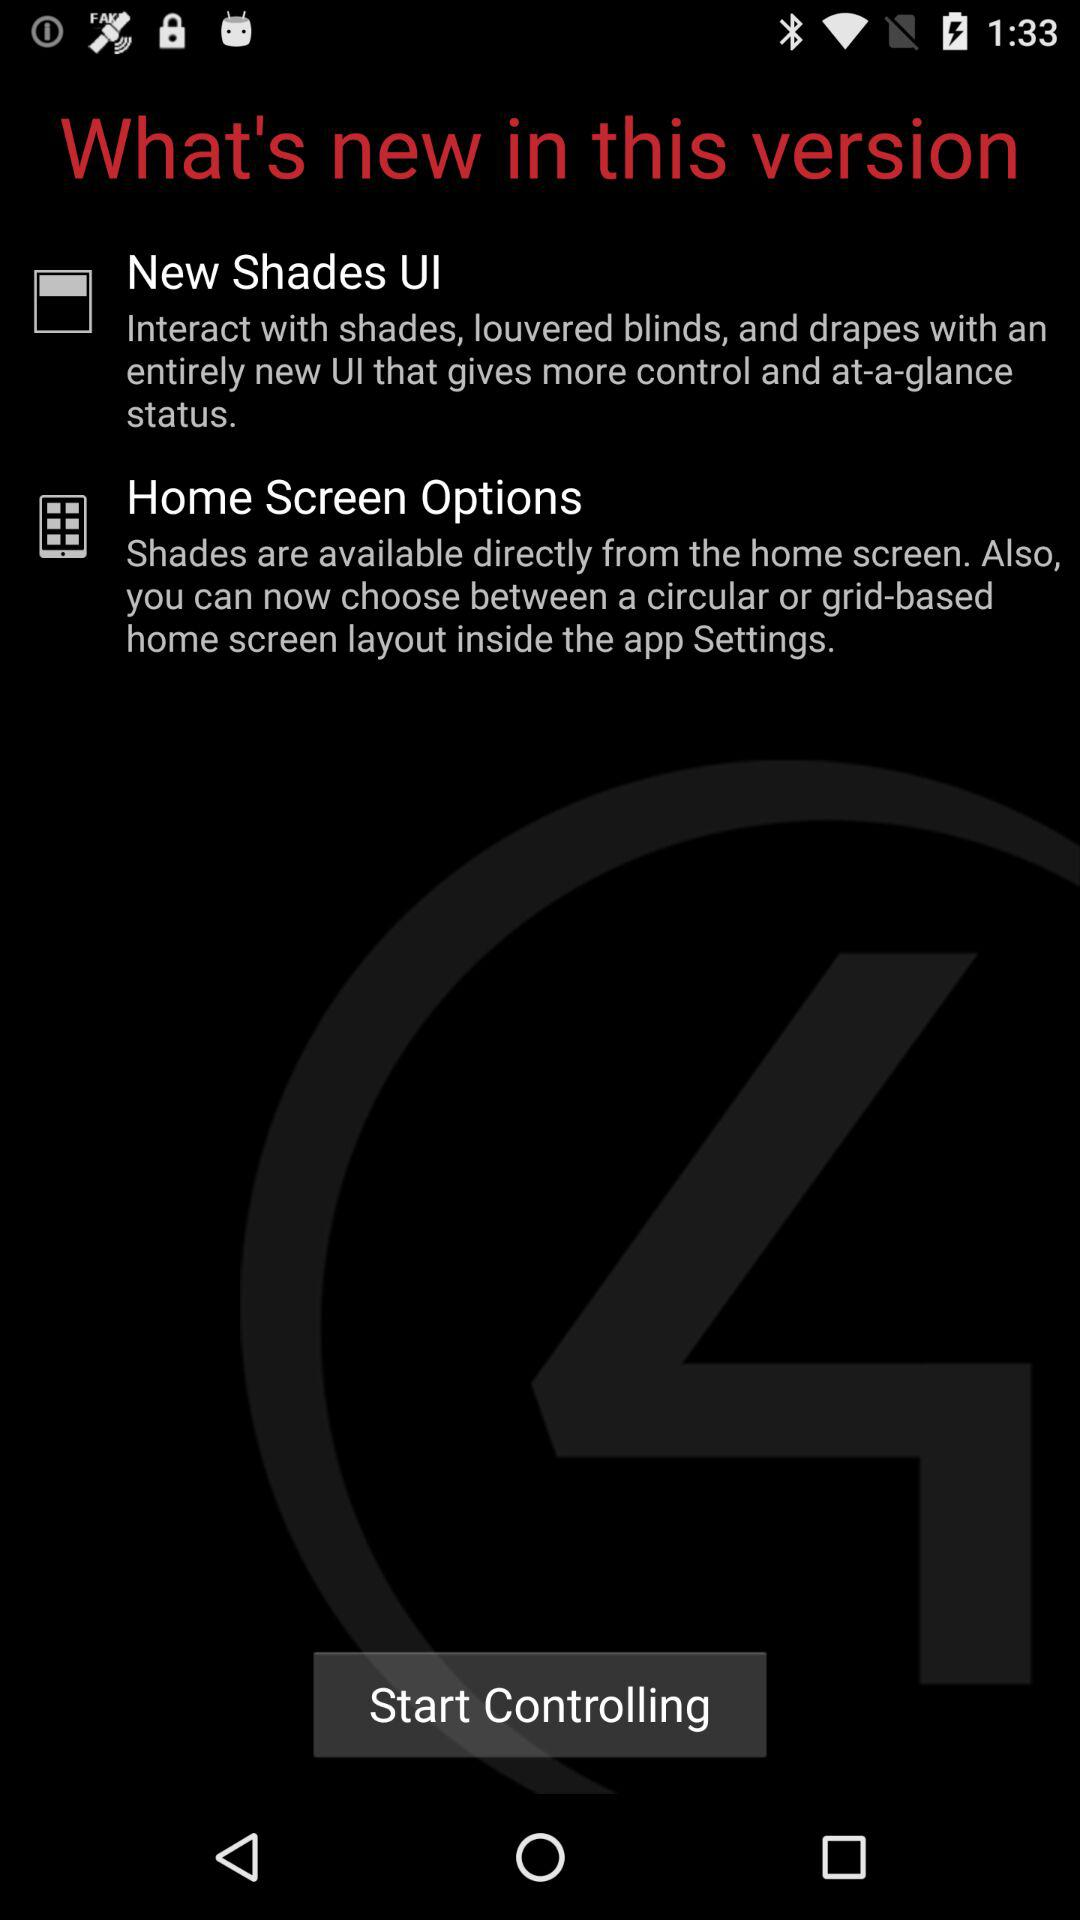What is new in this version? In this version, "New Shades UI" and "Home Screen Options" are new. 